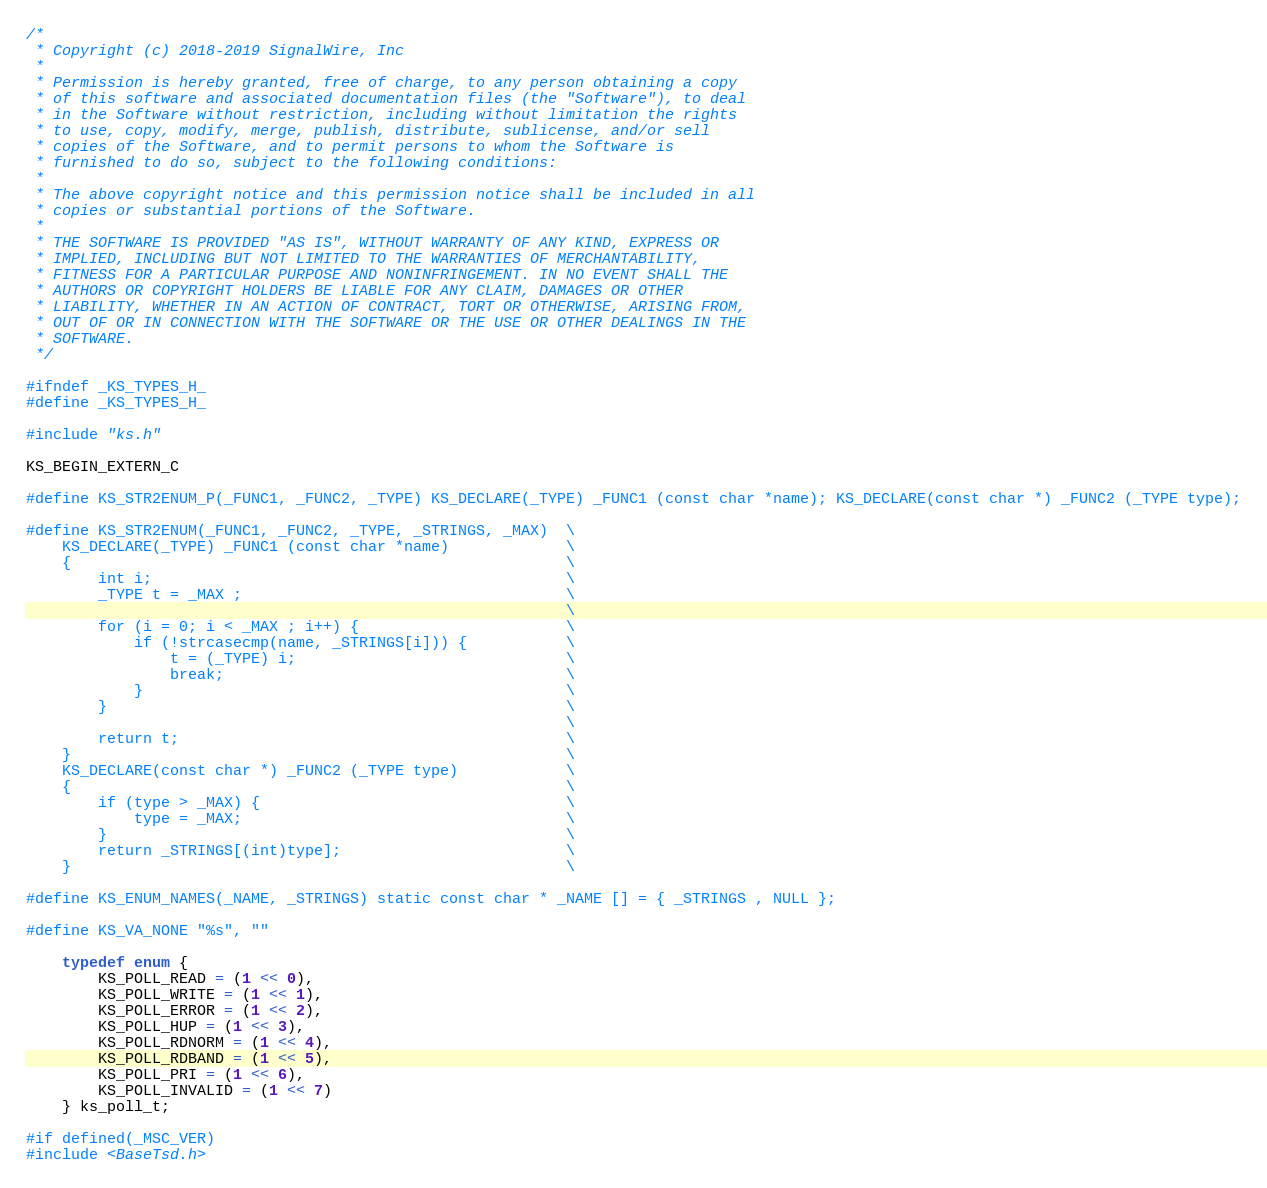Convert code to text. <code><loc_0><loc_0><loc_500><loc_500><_C_>/*
 * Copyright (c) 2018-2019 SignalWire, Inc
 *
 * Permission is hereby granted, free of charge, to any person obtaining a copy
 * of this software and associated documentation files (the "Software"), to deal
 * in the Software without restriction, including without limitation the rights
 * to use, copy, modify, merge, publish, distribute, sublicense, and/or sell
 * copies of the Software, and to permit persons to whom the Software is
 * furnished to do so, subject to the following conditions:
 *
 * The above copyright notice and this permission notice shall be included in all
 * copies or substantial portions of the Software.
 *
 * THE SOFTWARE IS PROVIDED "AS IS", WITHOUT WARRANTY OF ANY KIND, EXPRESS OR
 * IMPLIED, INCLUDING BUT NOT LIMITED TO THE WARRANTIES OF MERCHANTABILITY,
 * FITNESS FOR A PARTICULAR PURPOSE AND NONINFRINGEMENT. IN NO EVENT SHALL THE
 * AUTHORS OR COPYRIGHT HOLDERS BE LIABLE FOR ANY CLAIM, DAMAGES OR OTHER
 * LIABILITY, WHETHER IN AN ACTION OF CONTRACT, TORT OR OTHERWISE, ARISING FROM,
 * OUT OF OR IN CONNECTION WITH THE SOFTWARE OR THE USE OR OTHER DEALINGS IN THE
 * SOFTWARE.
 */

#ifndef _KS_TYPES_H_
#define _KS_TYPES_H_

#include "ks.h"

KS_BEGIN_EXTERN_C

#define KS_STR2ENUM_P(_FUNC1, _FUNC2, _TYPE) KS_DECLARE(_TYPE) _FUNC1 (const char *name); KS_DECLARE(const char *) _FUNC2 (_TYPE type);

#define KS_STR2ENUM(_FUNC1, _FUNC2, _TYPE, _STRINGS, _MAX)  \
    KS_DECLARE(_TYPE) _FUNC1 (const char *name)             \
    {                                                       \
        int i;                                              \
        _TYPE t = _MAX ;                                    \
                                                            \
        for (i = 0; i < _MAX ; i++) {                       \
            if (!strcasecmp(name, _STRINGS[i])) {           \
                t = (_TYPE) i;                              \
                break;                                      \
            }                                               \
        }                                                   \
                                                            \
        return t;                                           \
    }                                                       \
    KS_DECLARE(const char *) _FUNC2 (_TYPE type)            \
    {                                                       \
        if (type > _MAX) {                                  \
            type = _MAX;                                    \
        }                                                   \
        return _STRINGS[(int)type];                         \
    }                                                       \

#define KS_ENUM_NAMES(_NAME, _STRINGS) static const char * _NAME [] = { _STRINGS , NULL };

#define KS_VA_NONE "%s", ""

	typedef enum {
		KS_POLL_READ = (1 << 0),
		KS_POLL_WRITE = (1 << 1),
		KS_POLL_ERROR = (1 << 2),
		KS_POLL_HUP = (1 << 3),
		KS_POLL_RDNORM = (1 << 4),
		KS_POLL_RDBAND = (1 << 5),
		KS_POLL_PRI = (1 << 6),
		KS_POLL_INVALID = (1 << 7)
	} ks_poll_t;

#if defined(_MSC_VER)
#include <BaseTsd.h></code> 